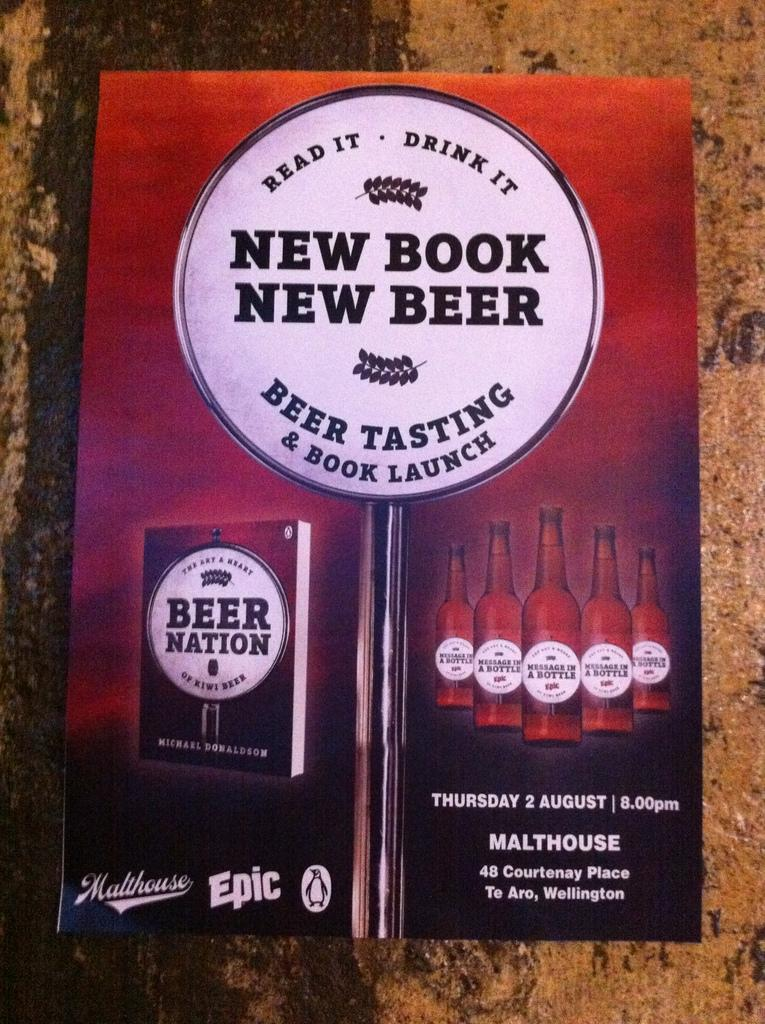<image>
Share a concise interpretation of the image provided. An advertisement for a new Beer Nation book 